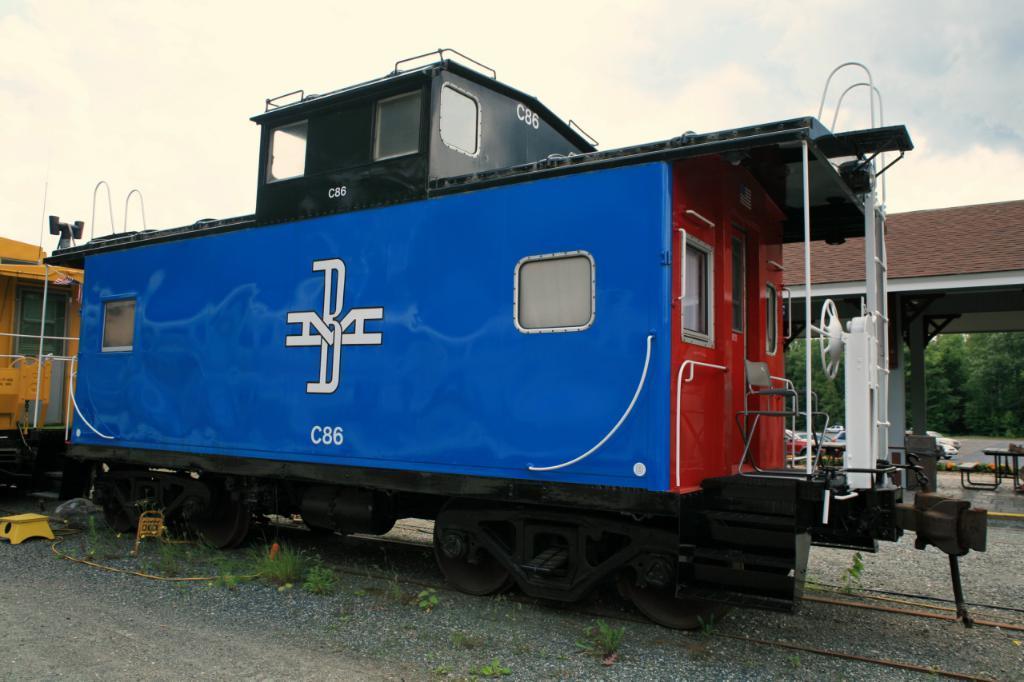Could you give a brief overview of what you see in this image? Here we can see a train in the picture, and here are the trees, and at above here is the sky. 